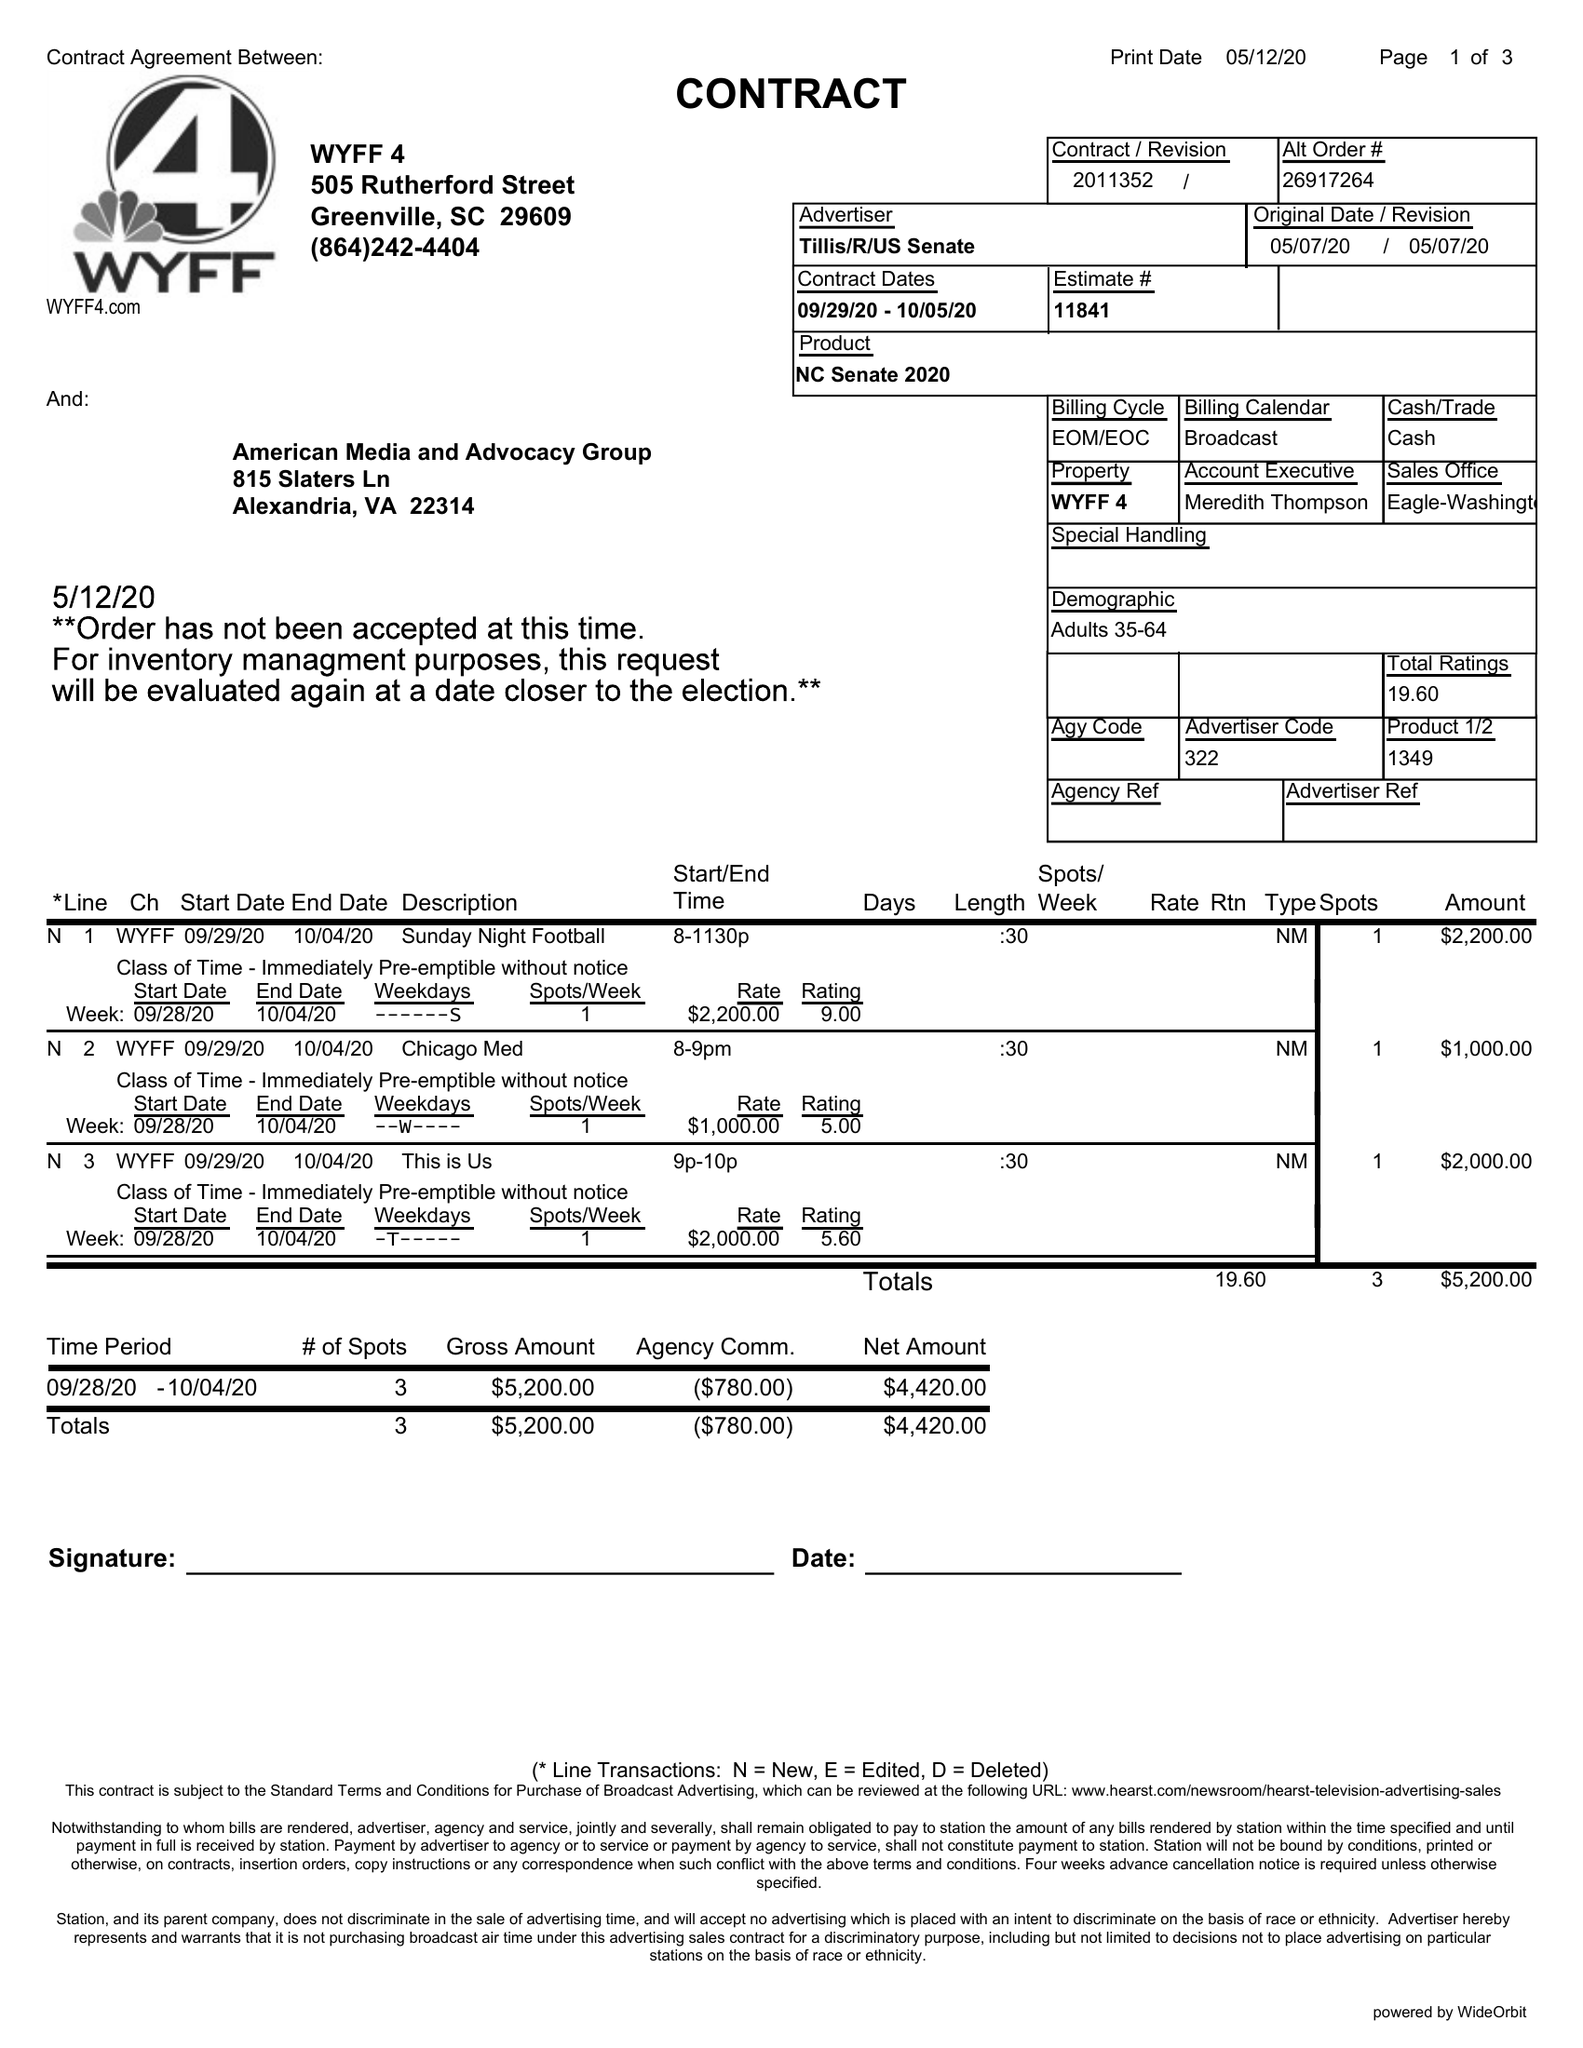What is the value for the advertiser?
Answer the question using a single word or phrase. TILLIS/R/USSENATE 